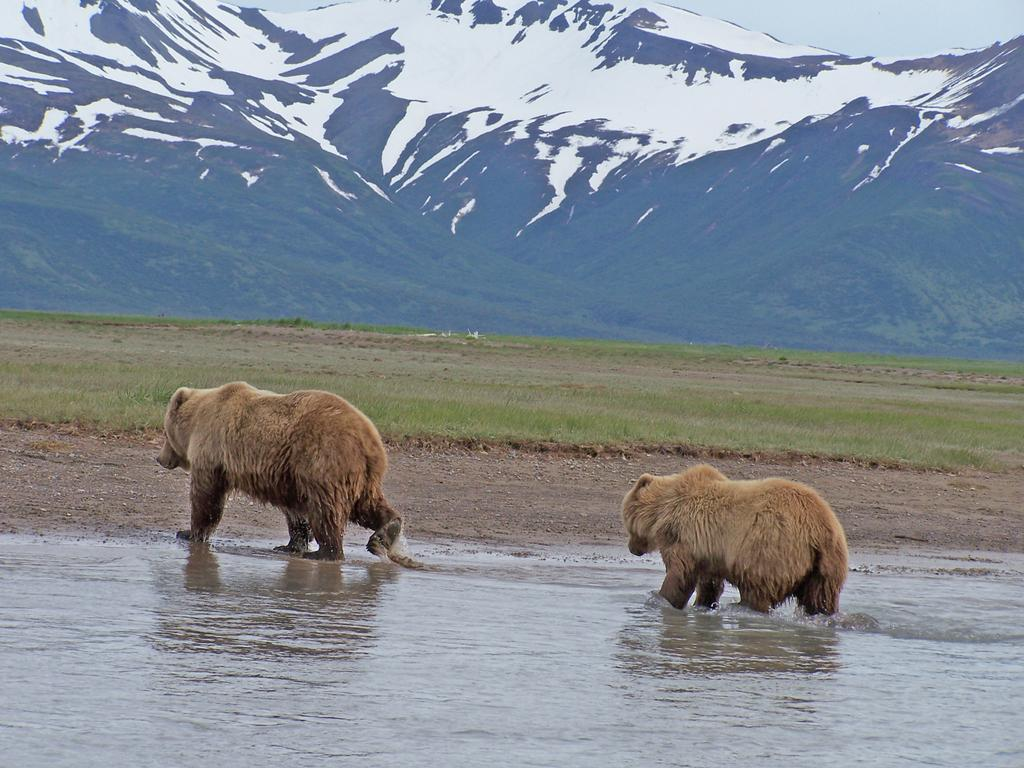How many bears are in the image? There are two bears in the image. What are the bears doing in the image? The bears are walking in the water. What can be seen in the background of the image? There is grass, hills with snow, and the sky visible in the background of the image. What type of humor can be seen in the bears' expressions in the image? There is no indication of the bears' expressions in the image, so it is not possible to determine the type of humor present. 